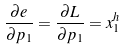<formula> <loc_0><loc_0><loc_500><loc_500>\frac { \partial e } { \partial p _ { 1 } } = \frac { \partial L } { \partial p _ { 1 } } = x _ { 1 } ^ { h }</formula> 